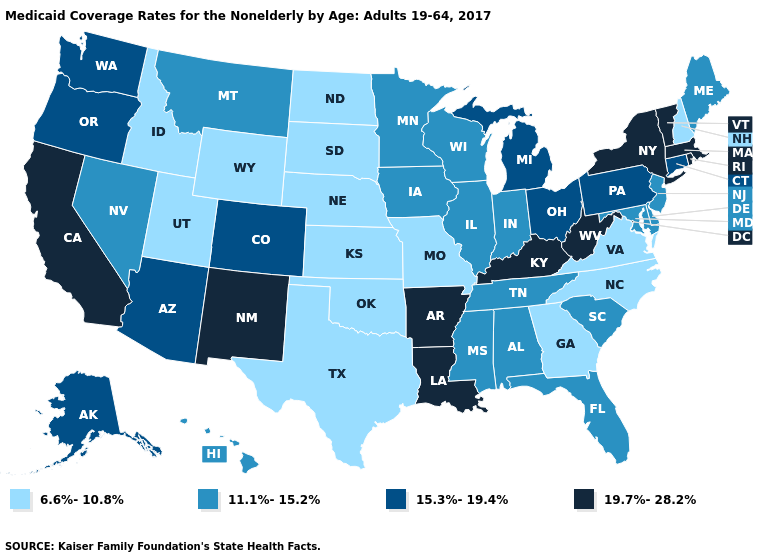Name the states that have a value in the range 15.3%-19.4%?
Be succinct. Alaska, Arizona, Colorado, Connecticut, Michigan, Ohio, Oregon, Pennsylvania, Washington. What is the value of Iowa?
Answer briefly. 11.1%-15.2%. What is the value of New Hampshire?
Answer briefly. 6.6%-10.8%. Name the states that have a value in the range 19.7%-28.2%?
Keep it brief. Arkansas, California, Kentucky, Louisiana, Massachusetts, New Mexico, New York, Rhode Island, Vermont, West Virginia. Name the states that have a value in the range 19.7%-28.2%?
Write a very short answer. Arkansas, California, Kentucky, Louisiana, Massachusetts, New Mexico, New York, Rhode Island, Vermont, West Virginia. Name the states that have a value in the range 19.7%-28.2%?
Answer briefly. Arkansas, California, Kentucky, Louisiana, Massachusetts, New Mexico, New York, Rhode Island, Vermont, West Virginia. Among the states that border Rhode Island , which have the highest value?
Concise answer only. Massachusetts. What is the lowest value in the MidWest?
Be succinct. 6.6%-10.8%. Name the states that have a value in the range 6.6%-10.8%?
Quick response, please. Georgia, Idaho, Kansas, Missouri, Nebraska, New Hampshire, North Carolina, North Dakota, Oklahoma, South Dakota, Texas, Utah, Virginia, Wyoming. Does Alaska have the same value as Arizona?
Write a very short answer. Yes. What is the value of Ohio?
Concise answer only. 15.3%-19.4%. Among the states that border Iowa , which have the highest value?
Short answer required. Illinois, Minnesota, Wisconsin. What is the value of Massachusetts?
Short answer required. 19.7%-28.2%. Among the states that border California , which have the highest value?
Concise answer only. Arizona, Oregon. 